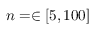Convert formula to latex. <formula><loc_0><loc_0><loc_500><loc_500>n = \in [ 5 , 1 0 0 ]</formula> 